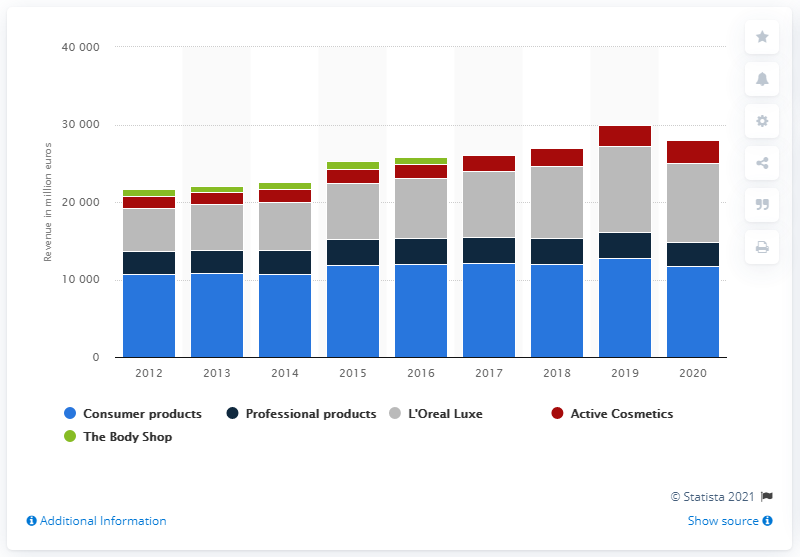Give some essential details in this illustration. In 2020, the consumer products division of L'Oréal generated a revenue of 117,03.8... 